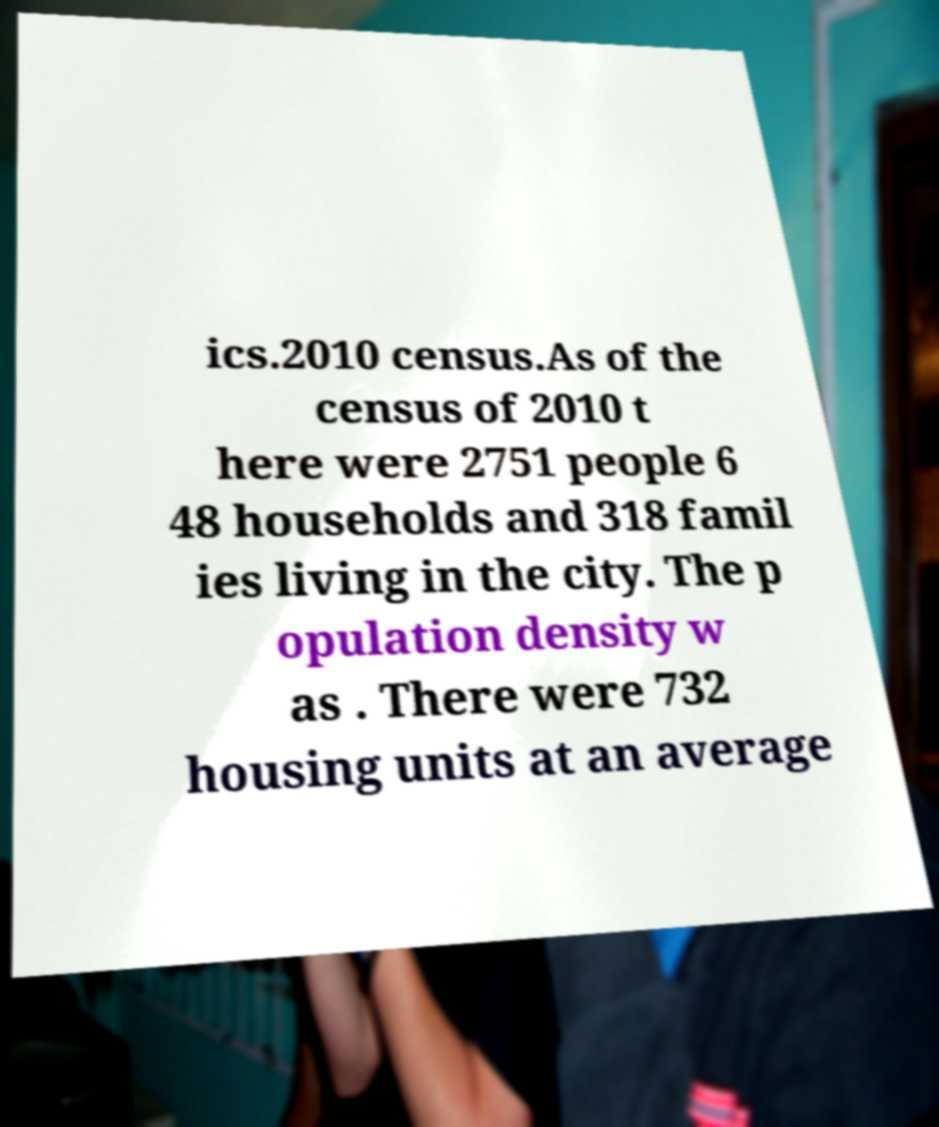Can you read and provide the text displayed in the image?This photo seems to have some interesting text. Can you extract and type it out for me? ics.2010 census.As of the census of 2010 t here were 2751 people 6 48 households and 318 famil ies living in the city. The p opulation density w as . There were 732 housing units at an average 